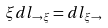<formula> <loc_0><loc_0><loc_500><loc_500>\xi d l _ { \rightarrow \xi } = d l _ { \xi \rightarrow }</formula> 